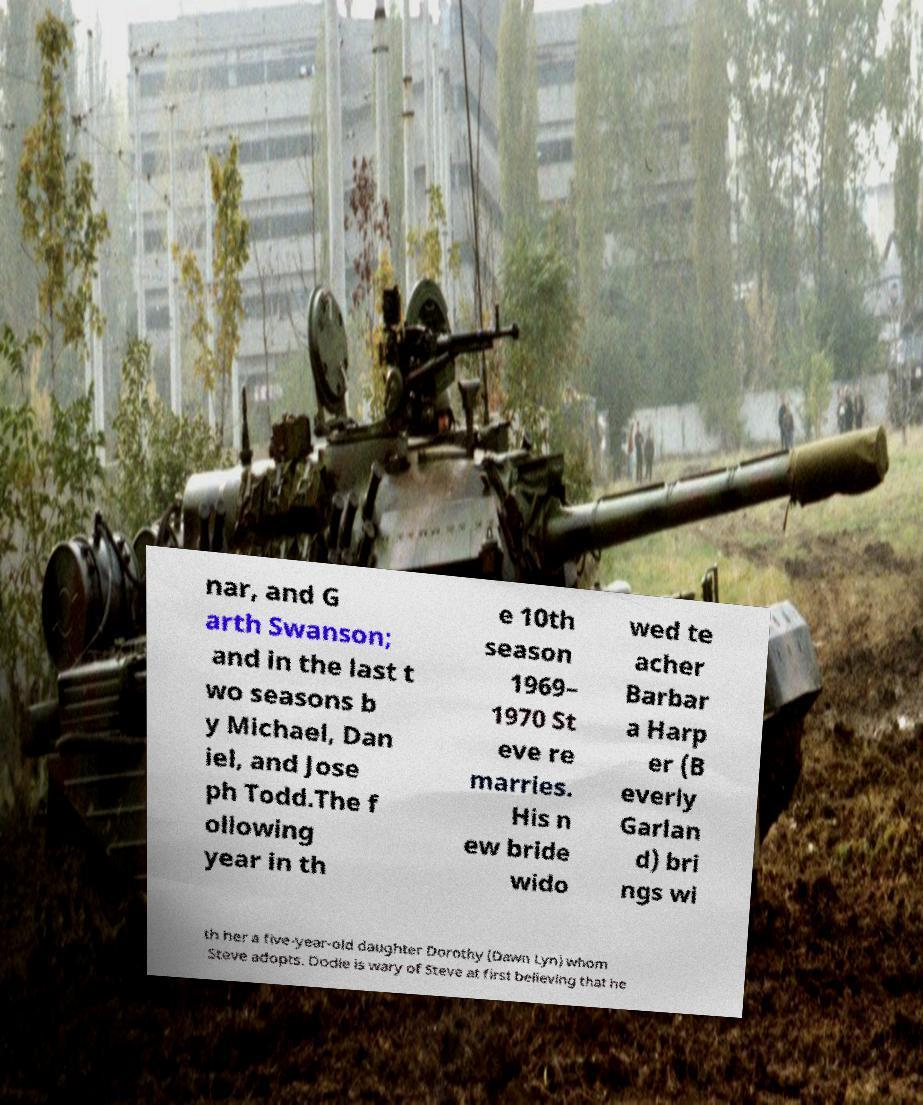Can you read and provide the text displayed in the image?This photo seems to have some interesting text. Can you extract and type it out for me? nar, and G arth Swanson; and in the last t wo seasons b y Michael, Dan iel, and Jose ph Todd.The f ollowing year in th e 10th season 1969– 1970 St eve re marries. His n ew bride wido wed te acher Barbar a Harp er (B everly Garlan d) bri ngs wi th her a five-year-old daughter Dorothy (Dawn Lyn) whom Steve adopts. Dodie is wary of Steve at first believing that he 